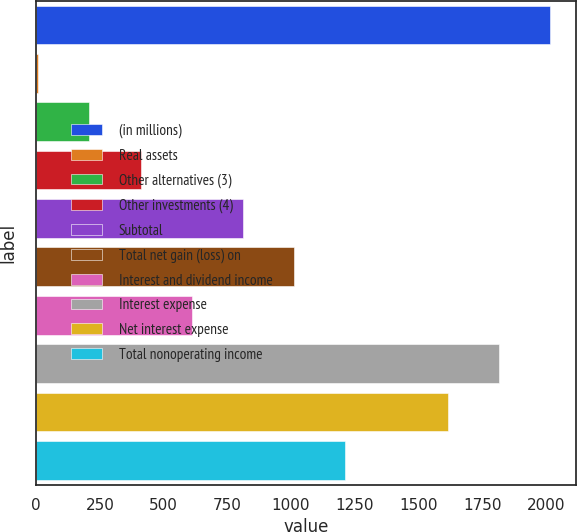Convert chart to OTSL. <chart><loc_0><loc_0><loc_500><loc_500><bar_chart><fcel>(in millions)<fcel>Real assets<fcel>Other alternatives (3)<fcel>Other investments (4)<fcel>Subtotal<fcel>Total net gain (loss) on<fcel>Interest and dividend income<fcel>Interest expense<fcel>Net interest expense<fcel>Total nonoperating income<nl><fcel>2016<fcel>8<fcel>208.8<fcel>409.6<fcel>811.2<fcel>1012<fcel>610.4<fcel>1815.2<fcel>1614.4<fcel>1212.8<nl></chart> 